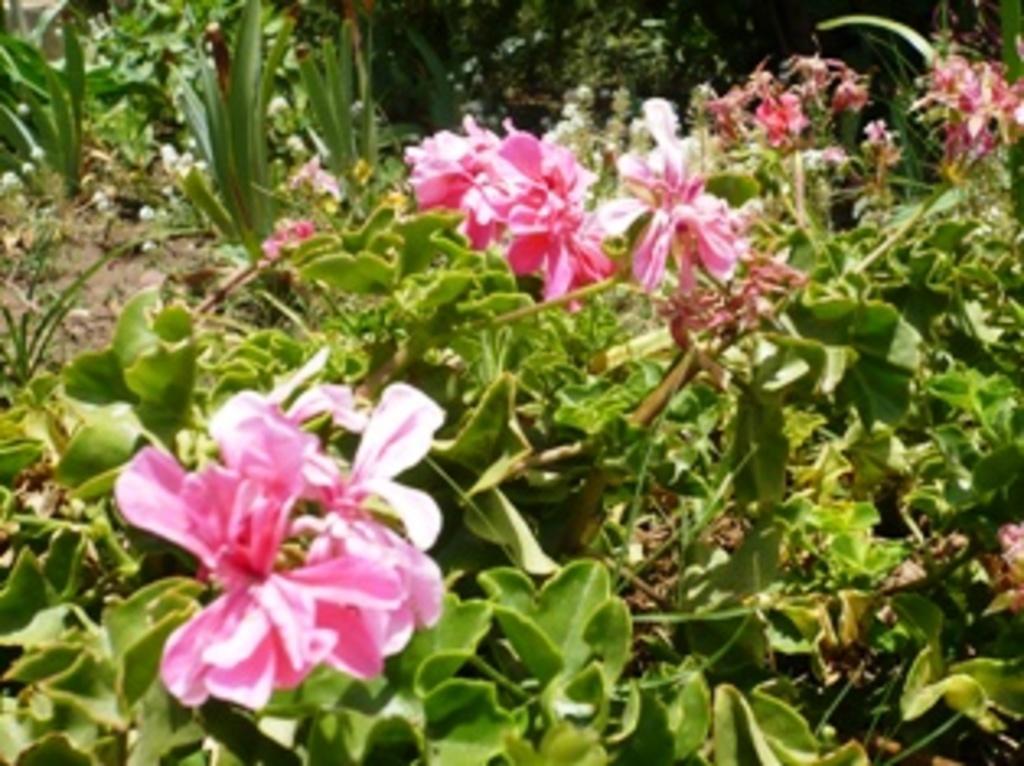Describe this image in one or two sentences. There are many plants with flowers. 